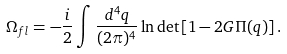<formula> <loc_0><loc_0><loc_500><loc_500>\Omega _ { f l } = - { \frac { i } { 2 } } \int { \frac { d ^ { 4 } q } { ( 2 \pi ) ^ { 4 } } } \ln \det \left [ 1 - 2 G \Pi ( q ) \right ] .</formula> 